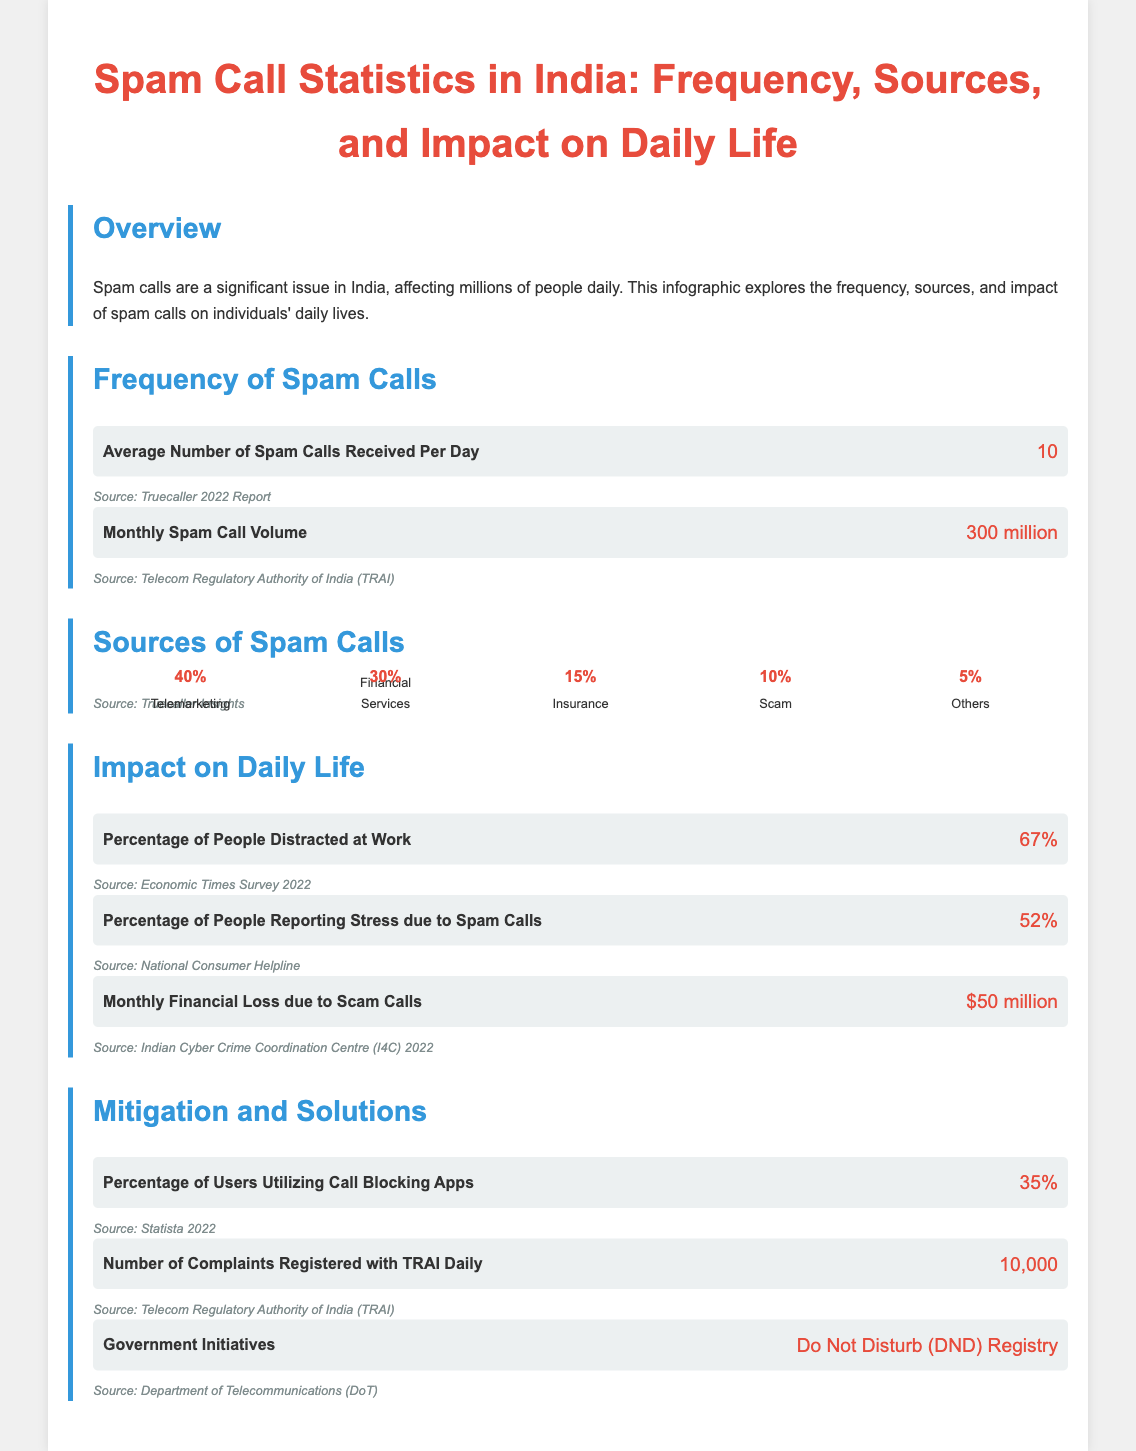What is the average number of spam calls received per day? The average number of spam calls is stated directly in the document.
Answer: 10 What percentage of spam calls come from telemarketing? This percentage is provided in the section about sources of spam calls.
Answer: 40% How many complaints are registered with TRAI daily? This information is mentioned in the section about mitigation and solutions.
Answer: 10,000 What is the percentage of people reporting stress due to spam calls? The document includes this percentage in the section on the impact of spam calls on daily life.
Answer: 52% What is the monthly spam call volume in India? The total volume is explicitly mentioned in the document.
Answer: 300 million What is the monthly financial loss due to scam calls? This figure is presented in the impact section of the infographic.
Answer: $50 million What is the percentage of users utilizing call blocking apps? This statistic is found in the section about mitigation and solutions.
Answer: 35% What government initiative is mentioned in the document? The document explicitly states the initiative aimed at reducing spam calls.
Answer: Do Not Disturb (DND) Registry 